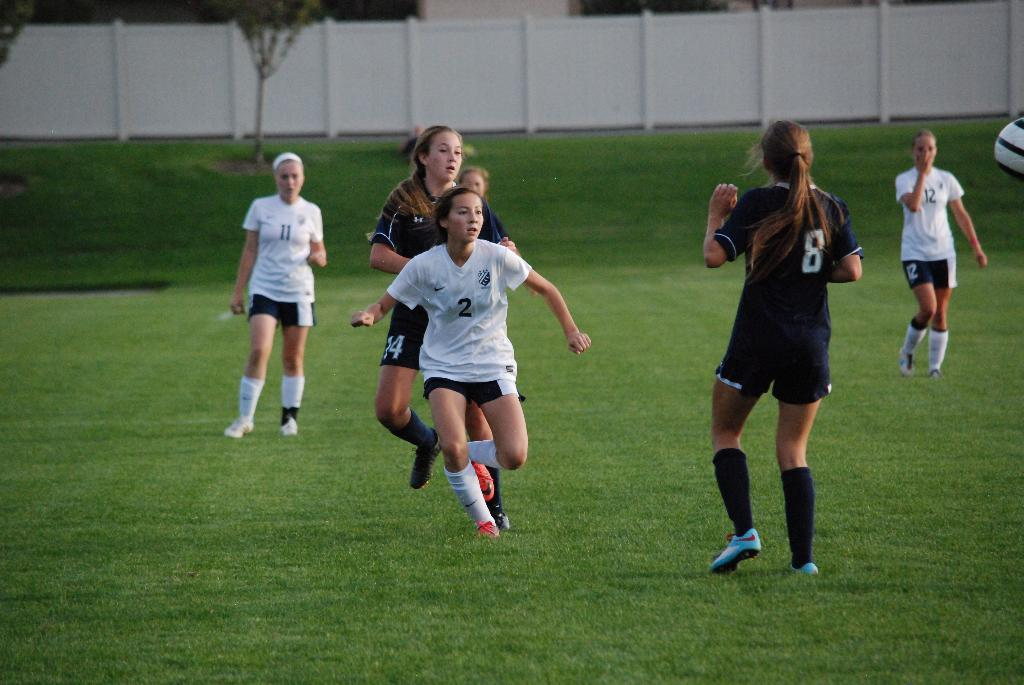How many girls are in the image? There is a group of girls in the image, but the exact number is not specified. Where are the girls located in the image? The girls are on the grass in the image. What can be seen in the background of the image? There is a wall, trees, and some objects in the background of the image. What type of engine can be seen in the image? There is no engine present in the image. Is the weather in the image sunny or cloudy? The provided facts do not mention the weather in the image, so it cannot be determined from the information given. 